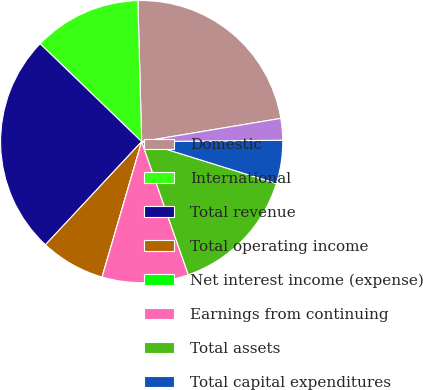<chart> <loc_0><loc_0><loc_500><loc_500><pie_chart><fcel>Domestic<fcel>International<fcel>Total revenue<fcel>Total operating income<fcel>Net interest income (expense)<fcel>Earnings from continuing<fcel>Total assets<fcel>Total capital expenditures<fcel>Total depreciation<nl><fcel>22.79%<fcel>12.37%<fcel>25.26%<fcel>7.42%<fcel>0.0%<fcel>9.89%<fcel>14.84%<fcel>4.95%<fcel>2.48%<nl></chart> 